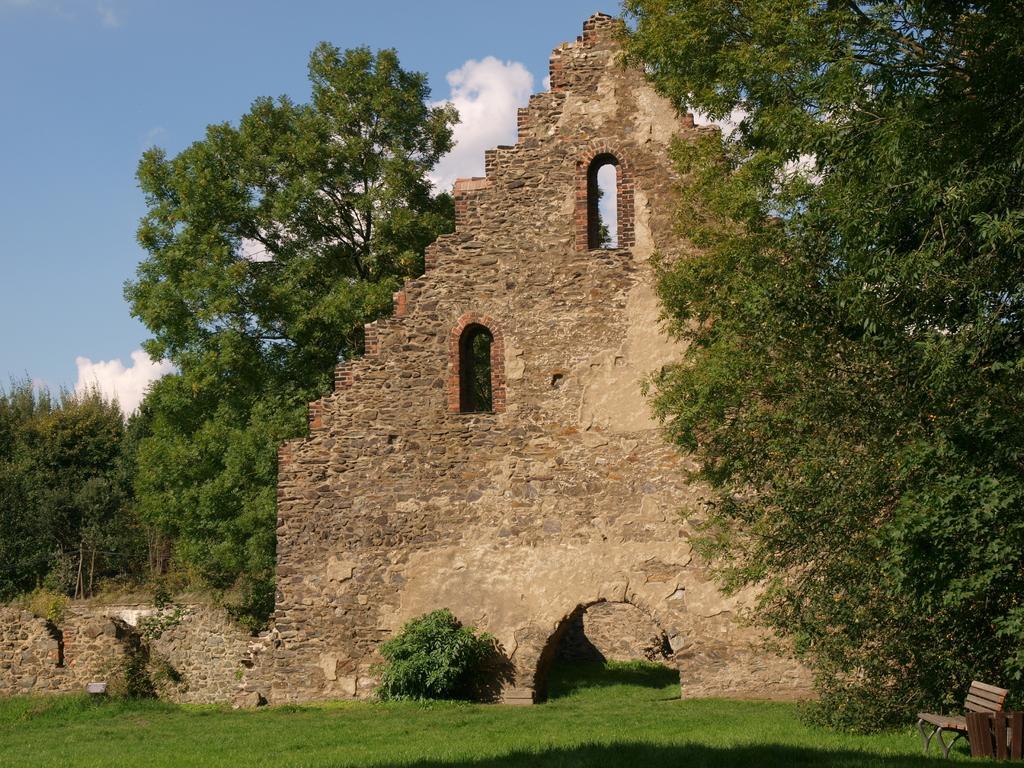Describe this image in one or two sentences. In the center of the image we can see building. On the right and left side of the image we can see trees. At the bottom of the image we can see tree and grass. In the background we can see clouds and sky. 